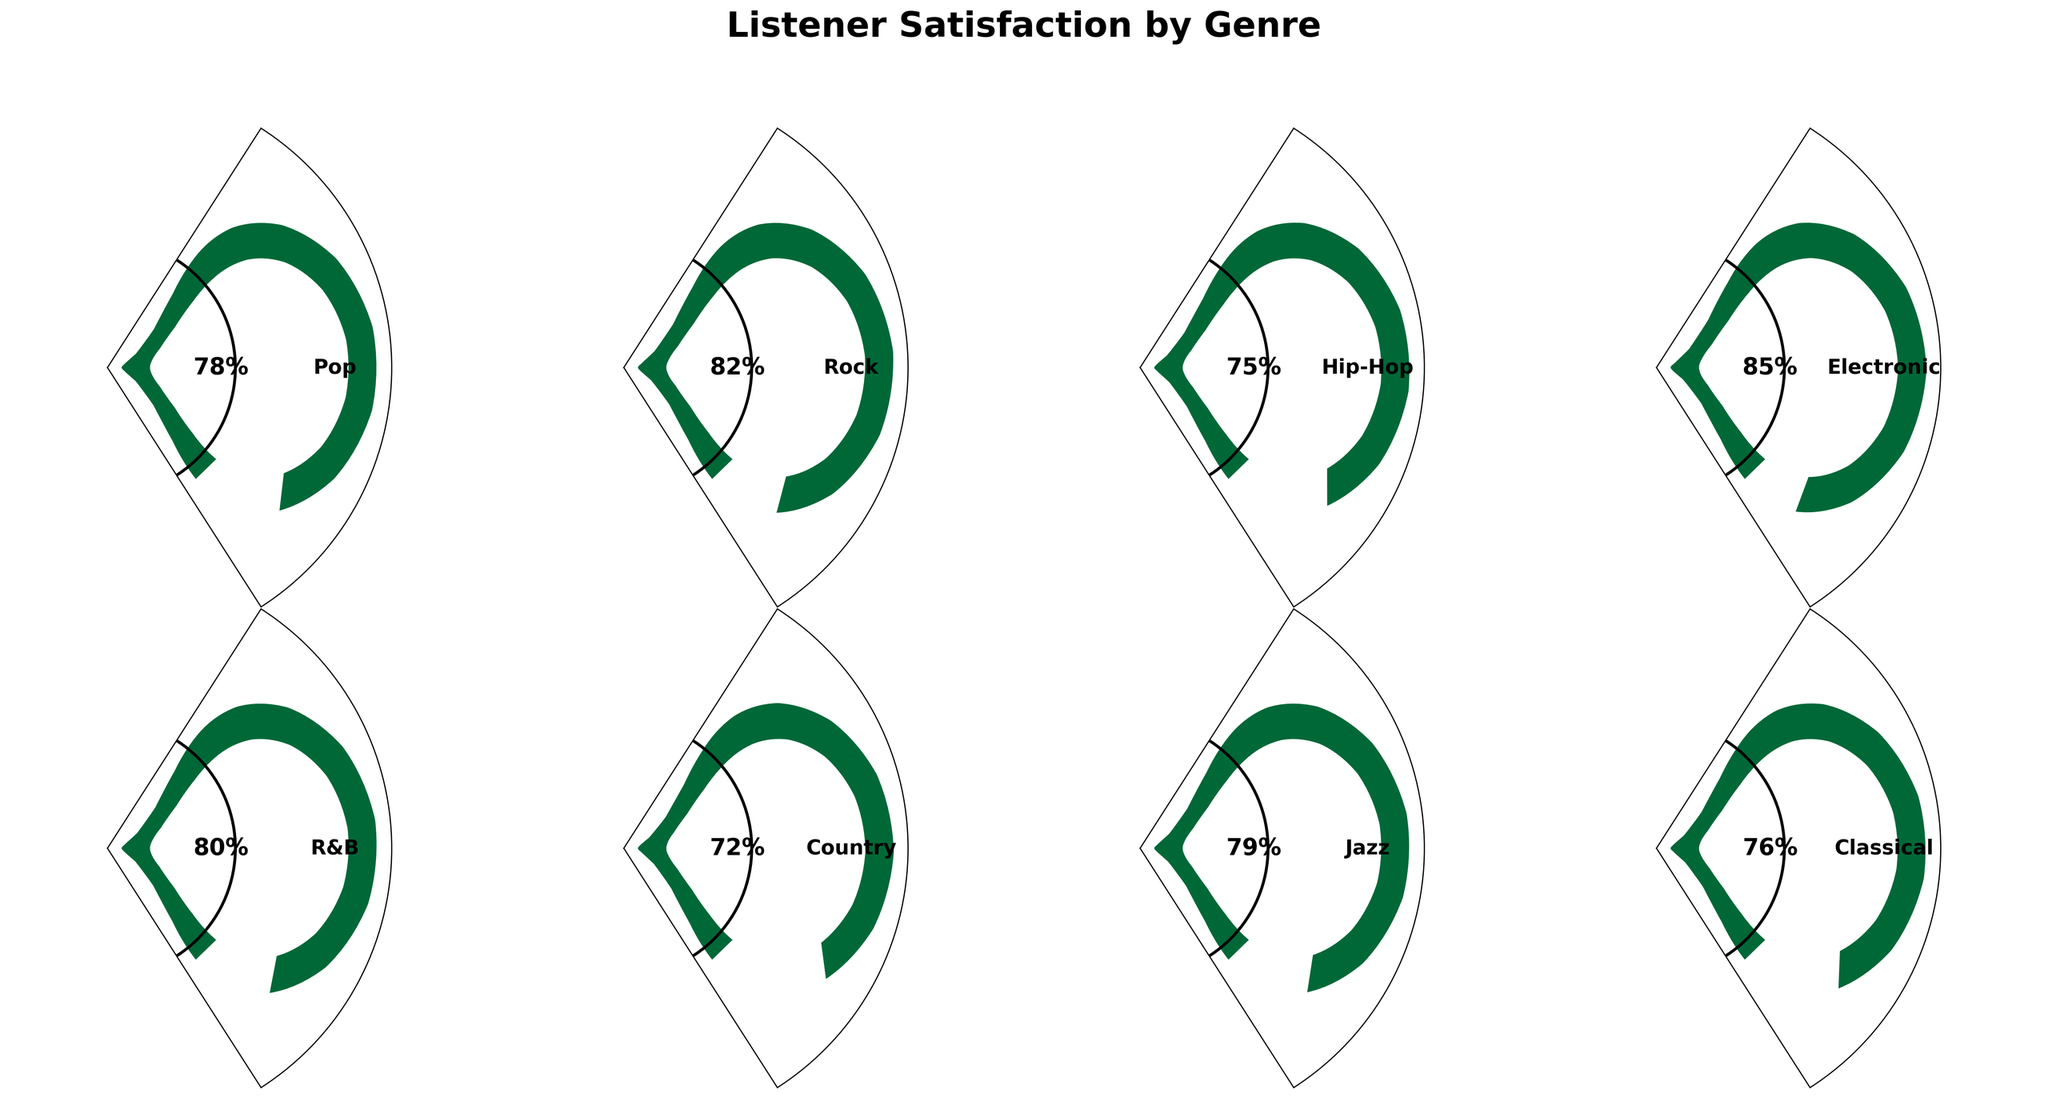Which genre has the highest listener satisfaction? The Electronic genre has the highest satisfaction rating of 85%, which is observed by identifying the highest percentage among all the genres.
Answer: Electronic Which genre has the lowest listener satisfaction? The Country genre possesses the lowest satisfaction rating, as seen with 72%, the smallest percentage among all the genres.
Answer: Country What is the satisfaction percentage for Jazz? The satisfaction percentage for Jazz can be seen directly on the gauge, which reads 79%.
Answer: 79% What is the average listener satisfaction across all genres? Add all the satisfaction percentages for each genre (78 + 82 + 75 + 85 + 80 + 72 + 79 + 76) and divide by the number of genres (8). (78 + 82 + 75 + 85 + 80 + 72 + 79 + 76) / 8 = 79.625
Answer: 79.625 How much higher is the satisfaction for Rock compared to Country? Subtract the satisfaction rating of Country (72) from that of Rock (82). 82 - 72 = 10
Answer: 10 Which two genres have satisfaction ratings within 2% of each other? By comparing the satisfaction ratings, the closest values are Jazz (79%) and Pop (78%) which are within a 1% difference.
Answer: Jazz and Pop What is the overall satisfaction trend across different genres? Observing the gauge charts, satisfaction ratings generally lie between 72% and 85%, with Electronic at the high end and Country at the low end, suggesting a broad but moderate satisfaction level.
Answer: Moderate satisfaction Which genre satisfaction is closest to the median satisfaction value, and what is this value? The ratings in sorted order are [72, 75, 76, 78, 79, 80, 82, 85]. The median satisfaction value is the average of the two middle values (78 and 79), so (78 + 79) / 2 = 78.5. Pop's satisfaction is 78, closest to 78.5.
Answer: Pop and 78 How many genres have a satisfaction rating above 80%? Count the genres with satisfaction ratings of > 80 on the gauges (Rock, Electronic, and R&B). There are 3 such genres.
Answer: 3 